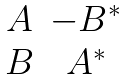Convert formula to latex. <formula><loc_0><loc_0><loc_500><loc_500>\begin{matrix} A & - B ^ { \ast } \\ B & A ^ { \ast } \end{matrix}</formula> 